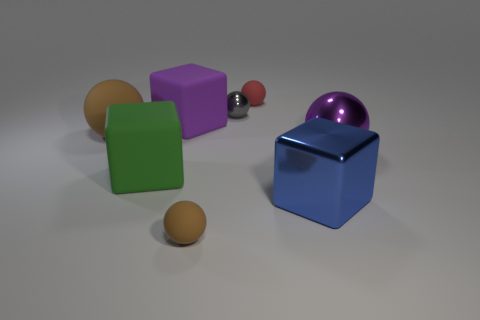Add 1 big metallic blocks. How many objects exist? 9 Subtract all red balls. How many balls are left? 4 Subtract all matte blocks. How many blocks are left? 1 Subtract all balls. How many objects are left? 3 Subtract 1 blocks. How many blocks are left? 2 Subtract all green cubes. Subtract all blue balls. How many cubes are left? 2 Subtract all red spheres. How many green cubes are left? 1 Subtract 0 brown cubes. How many objects are left? 8 Subtract all tiny rubber things. Subtract all gray objects. How many objects are left? 5 Add 3 big purple rubber blocks. How many big purple rubber blocks are left? 4 